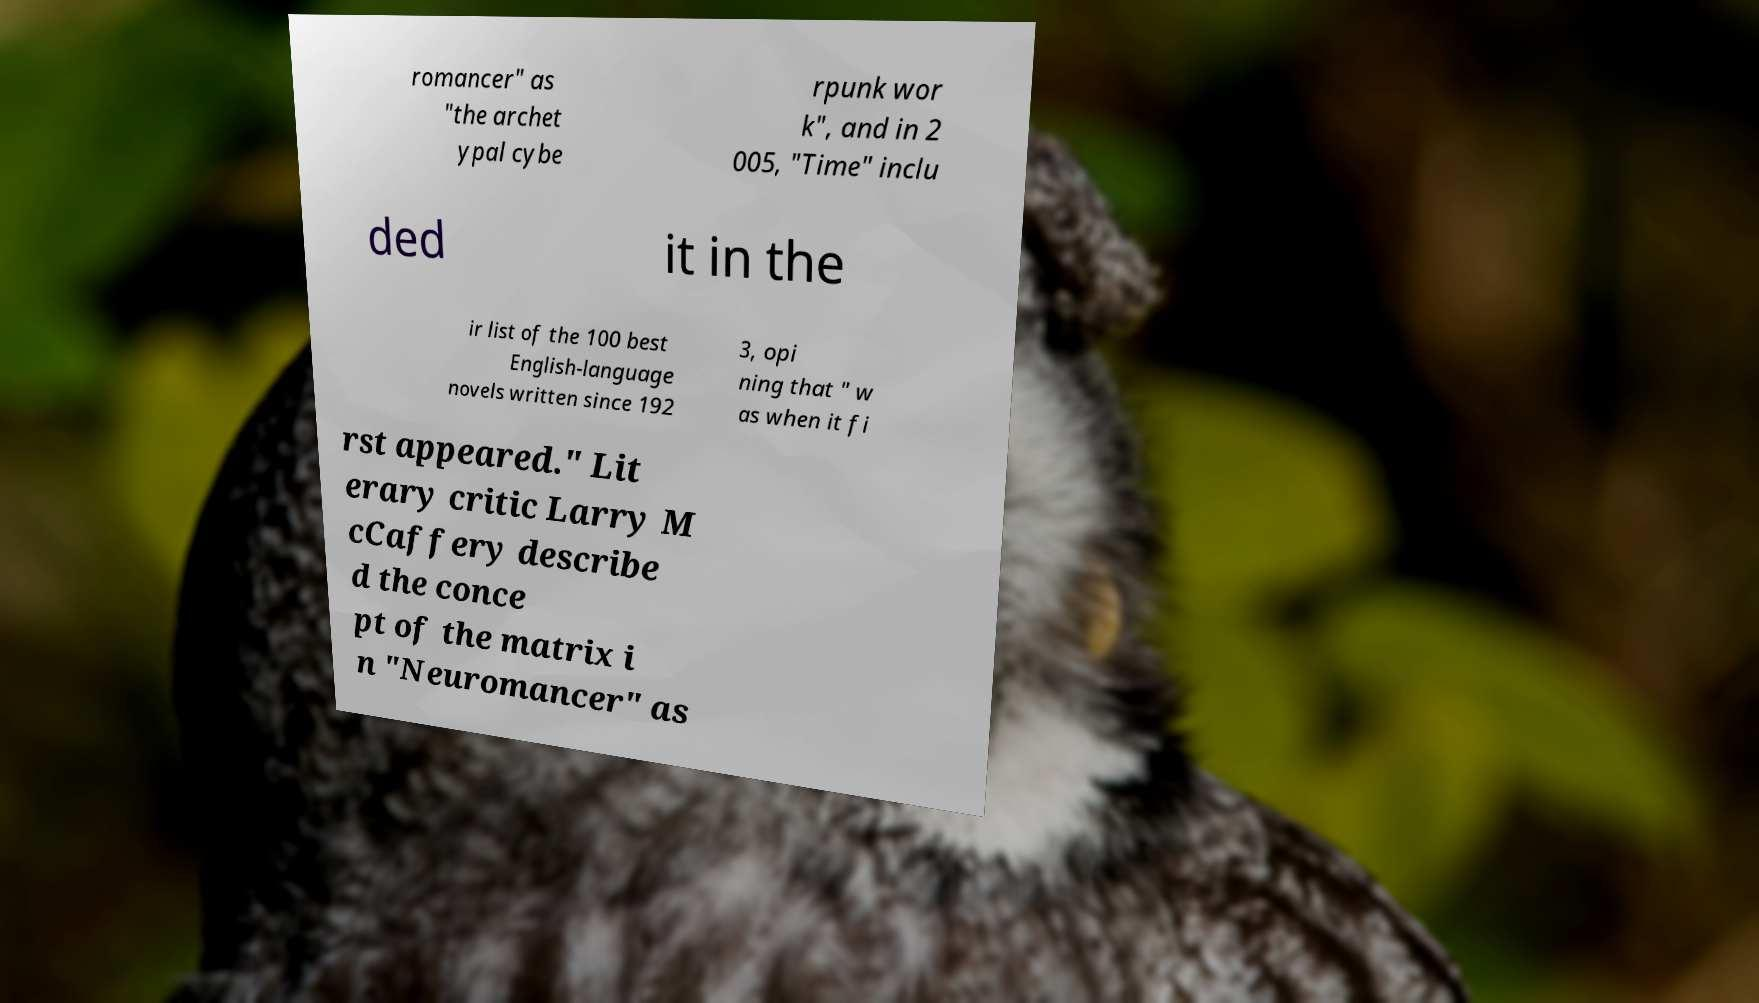I need the written content from this picture converted into text. Can you do that? romancer" as "the archet ypal cybe rpunk wor k", and in 2 005, "Time" inclu ded it in the ir list of the 100 best English-language novels written since 192 3, opi ning that " w as when it fi rst appeared." Lit erary critic Larry M cCaffery describe d the conce pt of the matrix i n "Neuromancer" as 